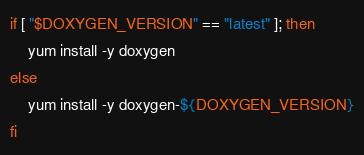<code> <loc_0><loc_0><loc_500><loc_500><_Bash_>if [ "$DOXYGEN_VERSION" == "latest" ]; then
    yum install -y doxygen
else
    yum install -y doxygen-${DOXYGEN_VERSION}
fi
</code> 